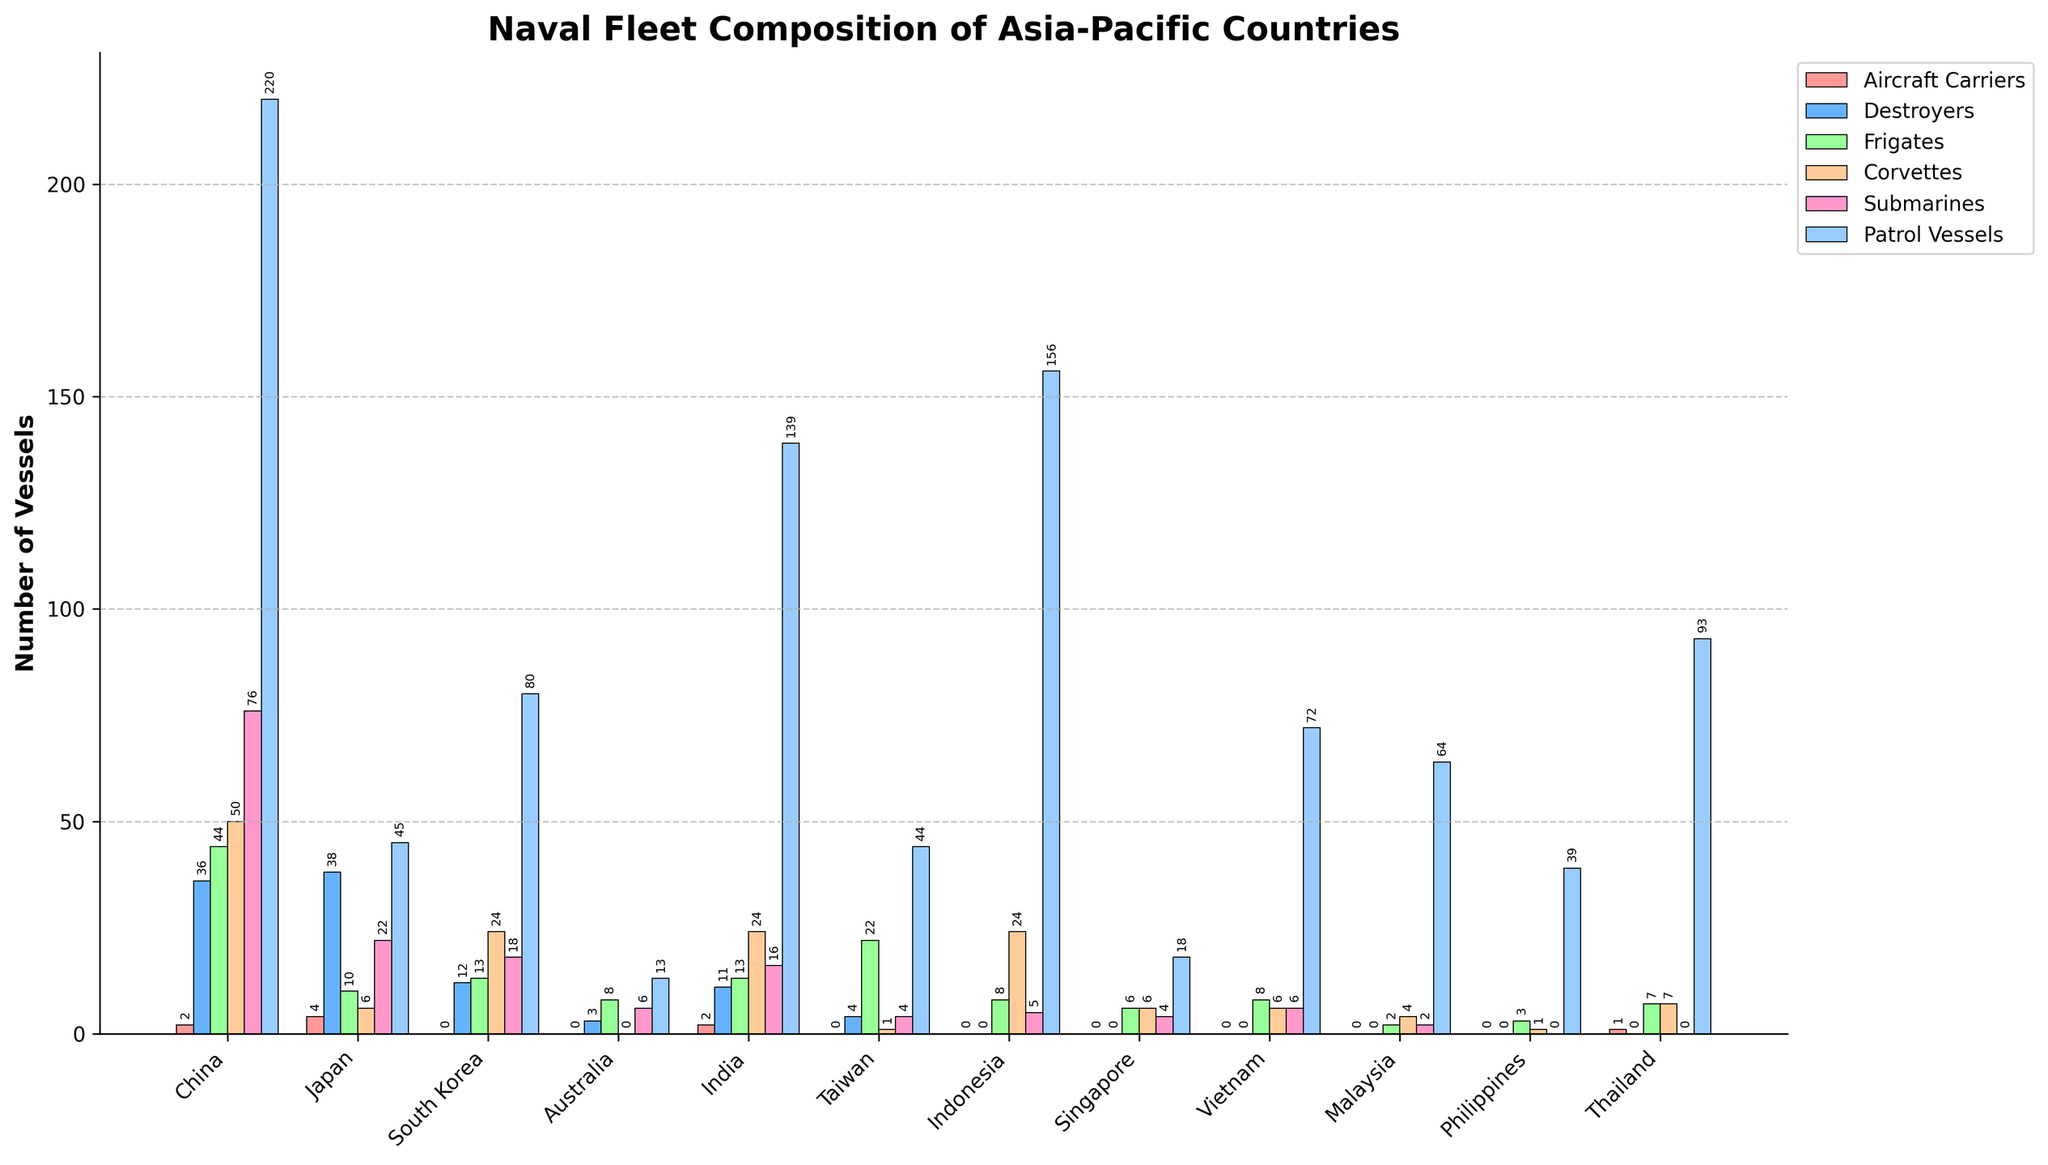What country has the highest number of patrol vessels? To determine the country with the highest number of patrol vessels, we look at the tallest bar in the "Patrol Vessels" category, which, based on the height, is associated with China.
Answer: China Which countries do not have any aircraft carriers? By observing the bars denoting aircraft carriers for each country, the countries with a bar height of zero in this category are South Korea, Australia, Taiwan, Indonesia, Singapore, Malaysia, and the Philippines.
Answer: South Korea, Australia, Taiwan, Indonesia, Singapore, Malaysia, Philippines What is the total number of submarines for China and India combined? To find the total number of submarines for China and India, we add the number of submarines for each country. China has 76 submarines and India has 16 submarines, so: 76 + 16 = 92.
Answer: 92 Which country has the most balanced distribution of different types of vessels (based on the bars' heights)? By analyzing the bars’ heights for each country, Japan seems to have relatively uniform bar heights, indicating a more balanced distribution across various vessel types compared to other countries with stark contrasts in bar heights.
Answer: Japan How many more destroyers does Japan have compared to South Korea? To find the difference in the number of destroyers between Japan and South Korea, we subtract South Korea's destroyer count from Japan's count. Japan has 38 destroyers, and South Korea has 12: 38 - 12 = 26.
Answer: 26 Which type of vessel is the most prevalent in Vietnam's naval fleet? By examining the height of the bars for each vessel type in Vietnam, the tallest bar represents patrol vessels.
Answer: Patrol Vessels Which country has the second-highest number of frigates? By identifying the country with the second tallest bar under the "Frigates" category, we see that Japan has 10 frigates, making it the second highest after China.
Answer: Japan Among the listed countries, who has the lowest number of corvettes? By comparing the height of the bars under the "Corvettes" category, Australia and the Philippines each have the lowest bar at 0.
Answer: Australia, Philippines What is the combined number of corvettes and submarines for South Korea? Adding the numbers of corvettes and submarines for South Korea, with 24 and 18 respectively: 24 + 18 = 42.
Answer: 42 How many total vessels does Malaysia have across all vessel types? To find the total number of vessels for Malaysia, we sum all the given numbers: 0 (Aircraft Carriers) + 0 (Destroyers) + 2 (Frigates) + 4 (Corvettes) + 2 (Submarines) + 64 (Patrol Vessels) = 72.
Answer: 72 